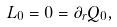<formula> <loc_0><loc_0><loc_500><loc_500>L _ { 0 } = 0 = \partial _ { r } Q _ { 0 } ,</formula> 